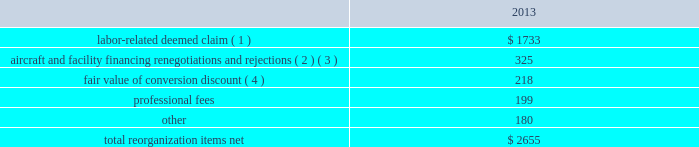Table of contents the following discussion of nonoperating income and expense excludes the results of the merger in order to provide a more meaningful year-over-year comparison .
Interest expense , net of capitalized interest decreased $ 249 million in 2014 from 2013 primarily due to a $ 149 million decrease in special charges recognized year-over-year as further described below , as well as refinancing activities that resulted in $ 100 million less interest expense recognized in 2014 .
( 1 ) in 2014 , we recognized $ 33 million of special charges relating to non-cash interest accretion on bankruptcy settlement obligations .
In 2013 , we recognized $ 138 million of special charges relating to post-petition interest expense on unsecured obligations pursuant to the plan and penalty interest related to american 2019s 10.5% ( 10.5 % ) secured notes and 7.50% ( 7.50 % ) senior secured notes .
In addition , in 2013 we recorded special charges of $ 44 million for debt extinguishment costs incurred as a result of the repayment of certain aircraft secured indebtedness , including cash interest charges and non-cash write offs of unamortized debt issuance costs .
( 2 ) as a result of the 2013 refinancing activities and the early extinguishment of american 2019s 7.50% ( 7.50 % ) senior secured notes in 2014 , we recognized $ 100 million less interest expense in 2014 as compared to 2013 .
Other nonoperating expense , net in 2014 consisted of $ 114 million of net foreign currency losses , including a $ 43 million special charge for venezuelan foreign currency losses , and $ 56 million in other nonoperating special charges primarily due to early debt extinguishment costs related to the prepayment of our 7.50% ( 7.50 % ) senior secured notes and other indebtedness .
The foreign currency losses were driven primarily by the strengthening of the u.s .
Dollar relative to other currencies during 2014 , principally in the latin american market , including a 48% ( 48 % ) decrease in the value of the venezuelan bolivar and a 14% ( 14 % ) decrease in the value of the brazilian real .
Other nonoperating expense , net in 2013 consisted principally of net foreign currency losses of $ 56 million and early debt extinguishment charges of $ 29 million .
Reorganization items , net reorganization items refer to revenues , expenses ( including professional fees ) , realized gains and losses and provisions for losses that are realized or incurred as a direct result of the chapter 11 cases .
The table summarizes the components included in reorganization items , net on aag 2019s consolidated statement of operations for the year ended december 31 , 2013 ( in millions ) : .
( 1 ) in exchange for employees 2019 contributions to the successful reorganization , including agreeing to reductions in pay and benefits , we agreed in the plan to provide each employee group a deemed claim , which was used to provide a distribution of a portion of the equity of the reorganized entity to those employees .
Each employee group received a deemed claim amount based upon a portion of the value of cost savings provided by that group through reductions to pay and benefits as well as through certain work rule changes .
The total value of this deemed claim was approximately $ 1.7 billion .
( 2 ) amounts include allowed claims ( claims approved by the bankruptcy court ) and estimated allowed claims relating to ( i ) the rejection or modification of financings related to aircraft and ( ii ) entry of orders treated as unsecured claims with respect to facility agreements supporting certain issuances of special facility revenue bonds .
The debtors recorded an estimated claim associated with the rejection or modification of a financing .
What is the percent of the labor-related deemed claim as part of the total reorganization items net in 2013? 
Computations: (1733 / 2655)
Answer: 0.65273. 